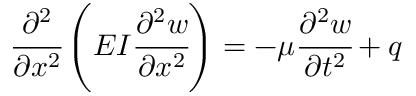Convert formula to latex. <formula><loc_0><loc_0><loc_500><loc_500>{ \cfrac { \partial ^ { 2 } } { \partial x ^ { 2 } } } \left ( E I { \cfrac { \partial ^ { 2 } w } { \partial x ^ { 2 } } } \right ) = - \mu { \cfrac { \partial ^ { 2 } w } { \partial t ^ { 2 } } } + q</formula> 